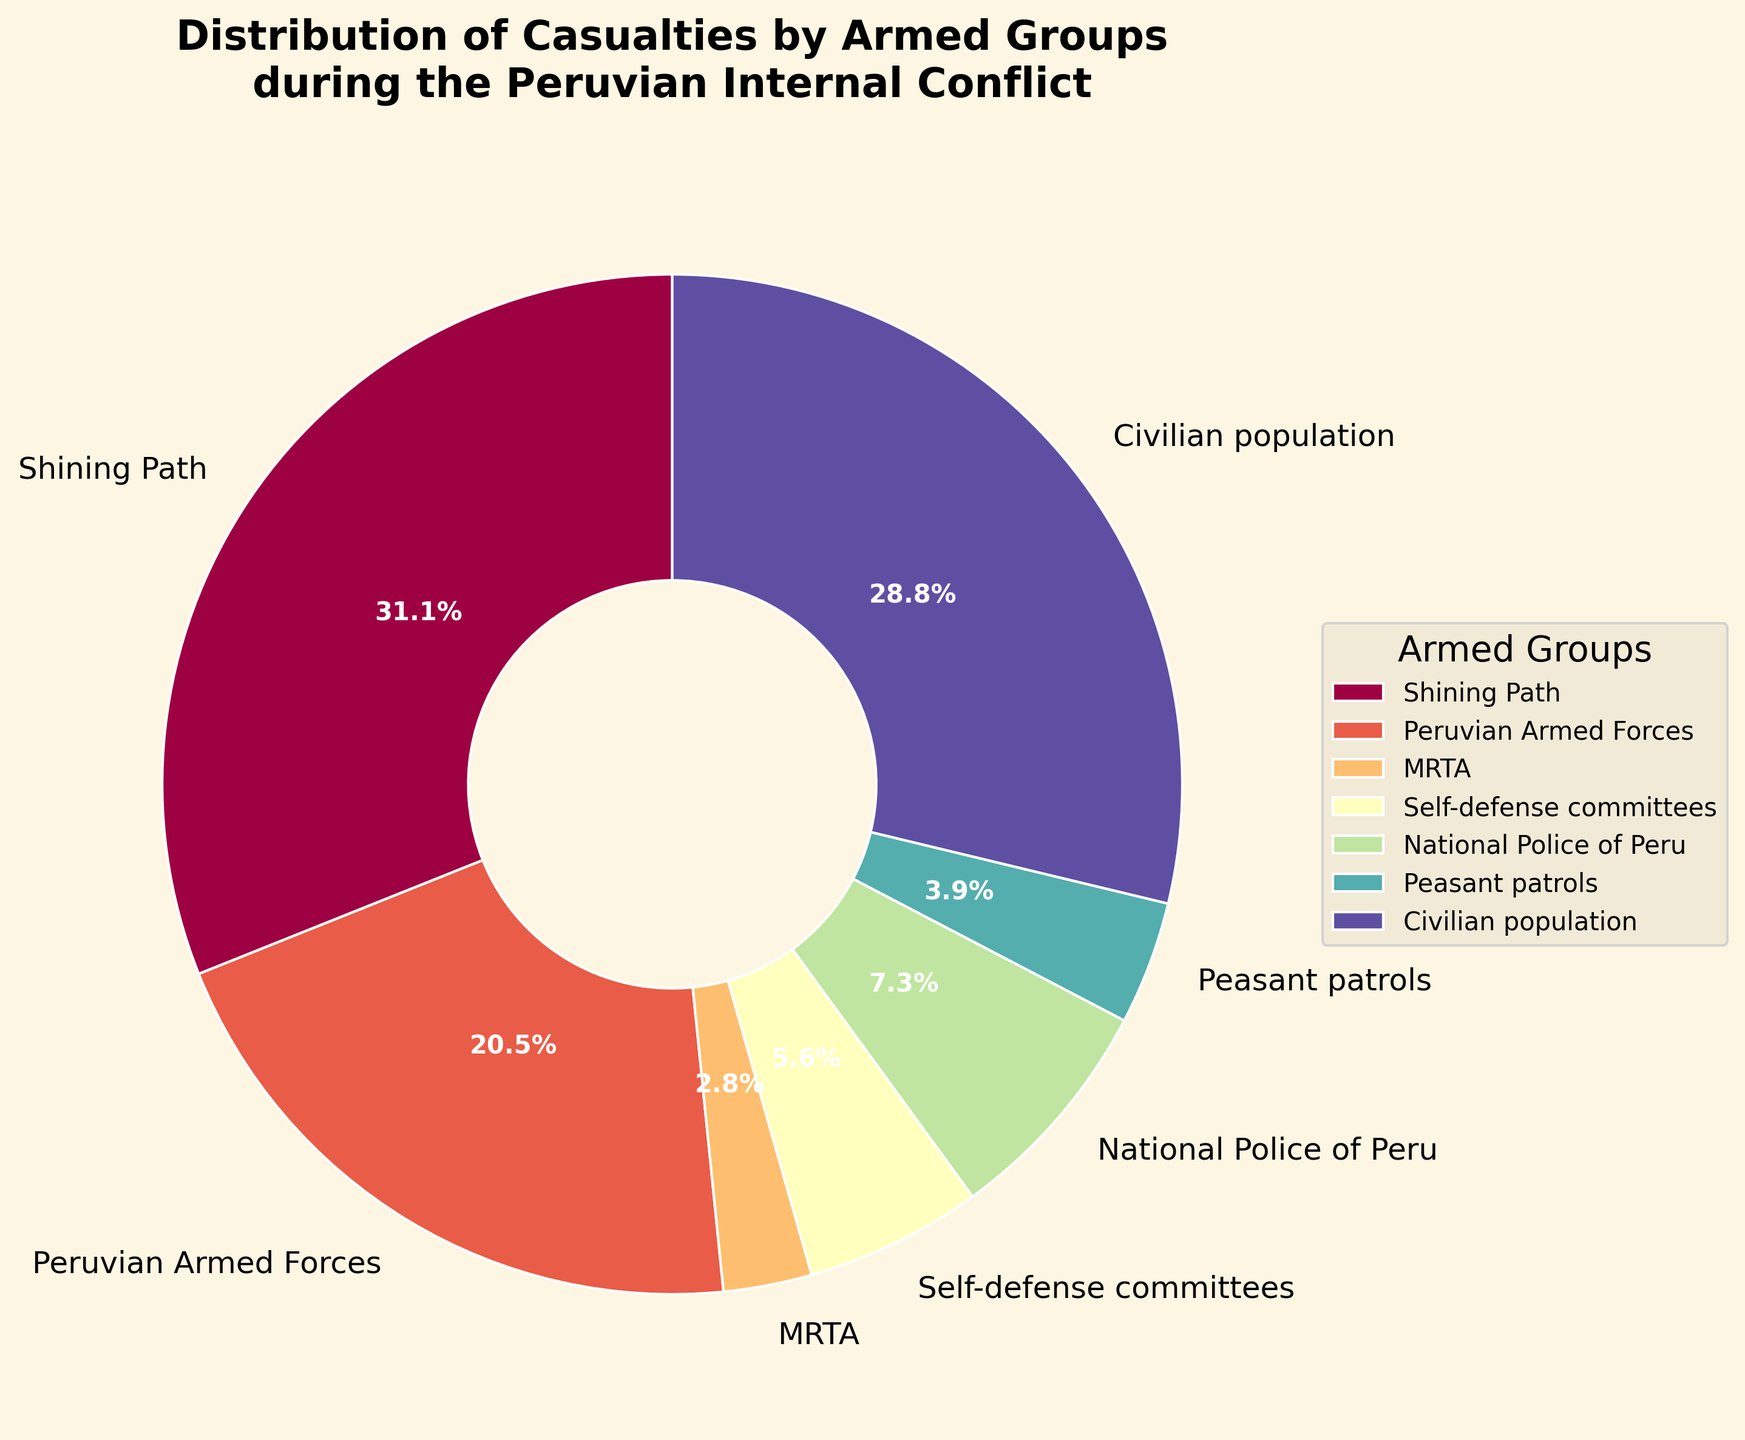Which armed group is responsible for the highest percentage of casualties? The pie chart shows that the Shining Path has the largest wedge with 31,000 casualties, which is the highest among all groups.
Answer: Shining Path What is the combined percentage of casualties caused by the Peruvian Armed Forces and the National Police of Peru? Add the percentages of the Peruvian Armed Forces (20,500 casualties) and the National Police of Peru (7,300 casualties). This requires calculating their combined percentage of the total casualties.
Answer: 21.6% Which group has fewer casualties, MRTA or Self-defense committees? Compare the pie chart wedges for MRTA (2,800 casualties) and Self-defense committees (5,600 casualties).
Answer: MRTA How many casualties are attributed to non-state actors (Shining Path, MRTA, Self-defense committees, Peasant patrols)? Sum the casualties for Shining Path (31,000), MRTA (2,800), Self-defense committees (5,600), and Peasant patrols (3,900).
Answer: 43,300 What is the percentage difference in casualties between Shining Path and the Civilian Population? Find the percentages for Shining Path (31,000 casualties) and Civilian Population (28,700 casualties), then calculate the absolute difference between the two percentages.
Answer: 2.4% Which armed group has a wedge with a purple gradient color? Identify the wedge associated with Self-defense committees in the color scheme, which uses a purple gradient.
Answer: Self-defense committees How does the percentage of casualties caused by Peasant patrols compare to that of MRTA? Compare the wedges for Peasant patrols (3,900 casualties) and MRTA (2,800 casualties) in terms of percentage on the pie chart.
Answer: Peasant patrols have a higher percentage What is the total number of casualties represented in the pie chart? Sum up all the casualties from each group: Shining Path (31,000), Peruvian Armed Forces (20,500), MRTA (2,800), Self-defense committees (5,600), National Police of Peru (7,300), Peasant patrols (3,900), and Civilian population (28,700).
Answer: 99,800 Which two groups together account for approximately half of the total casualties? Add the percentages for the Shining Path (31,000 casualties) and the Civilian population (28,700 casualties).
Answer: Shining Path and Civilian population 